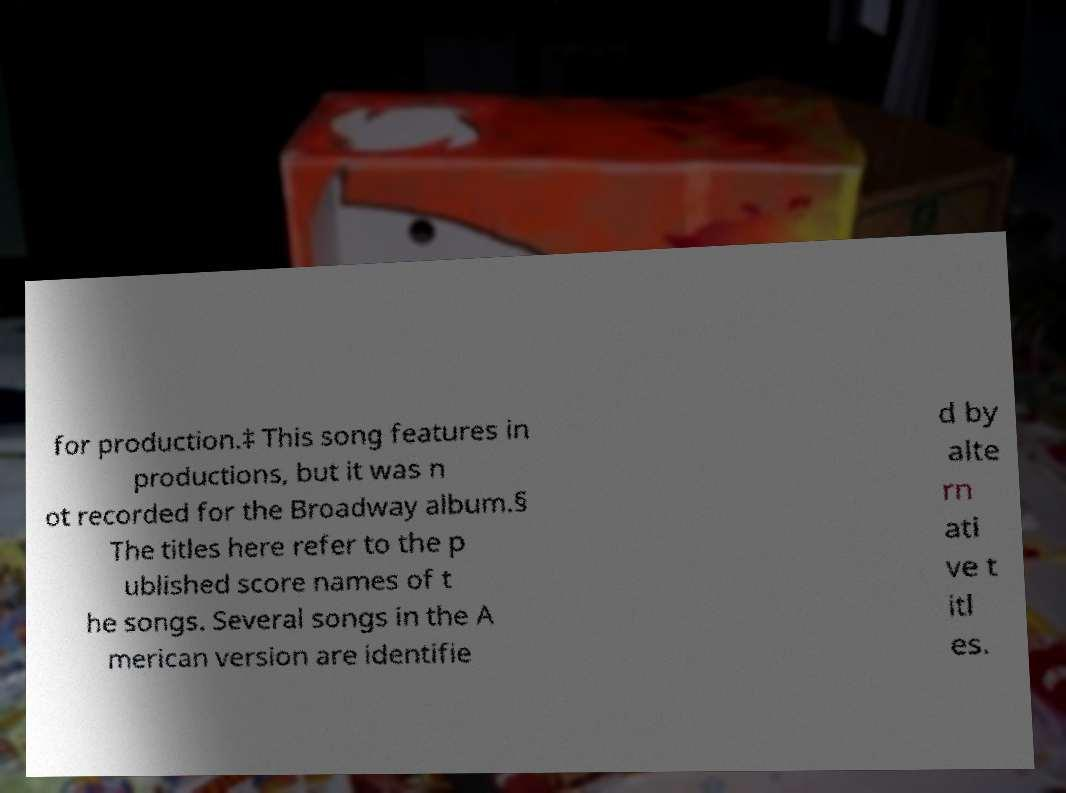Please read and relay the text visible in this image. What does it say? for production.‡ This song features in productions, but it was n ot recorded for the Broadway album.§ The titles here refer to the p ublished score names of t he songs. Several songs in the A merican version are identifie d by alte rn ati ve t itl es. 